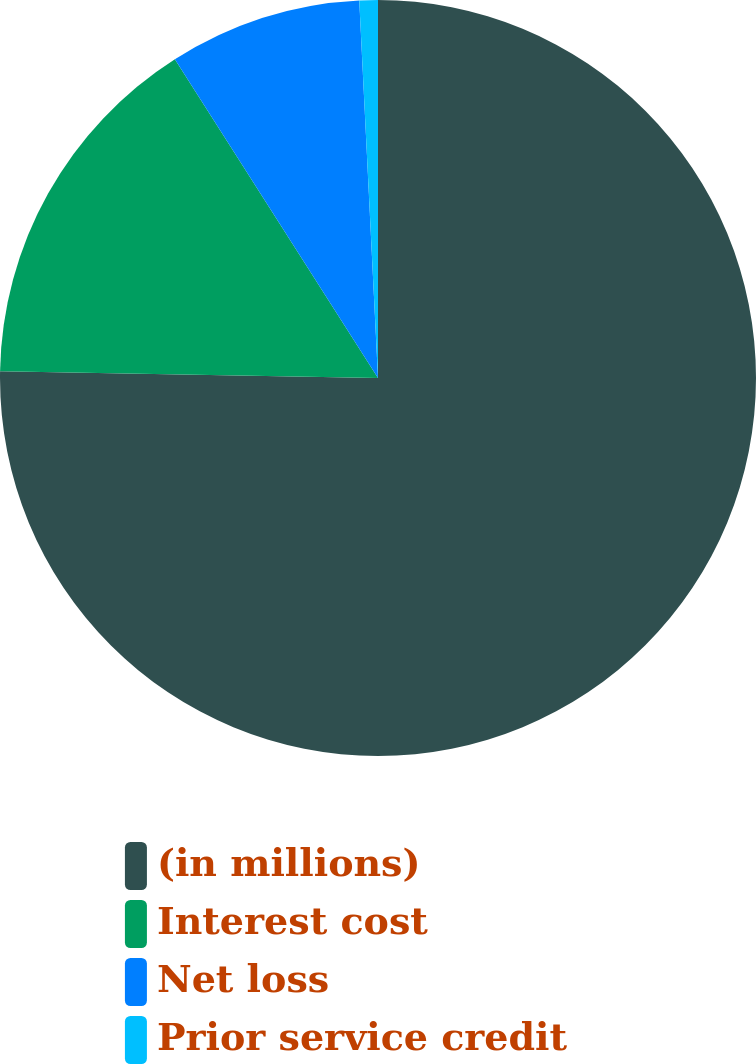Convert chart. <chart><loc_0><loc_0><loc_500><loc_500><pie_chart><fcel>(in millions)<fcel>Interest cost<fcel>Net loss<fcel>Prior service credit<nl><fcel>75.29%<fcel>15.69%<fcel>8.24%<fcel>0.79%<nl></chart> 